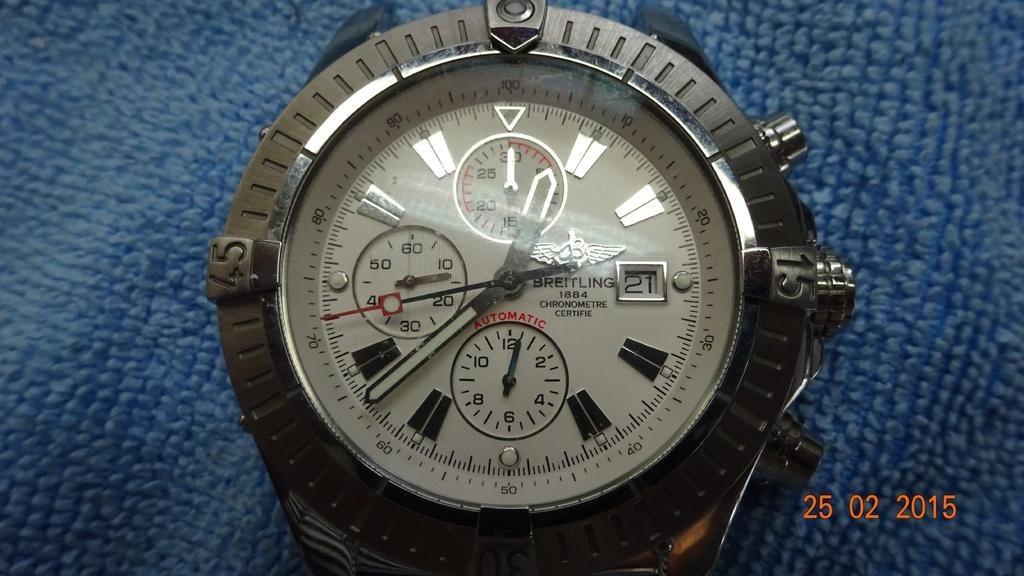Provide a one-sentence caption for the provided image. A Breitling chronometre watch on a blue background. 